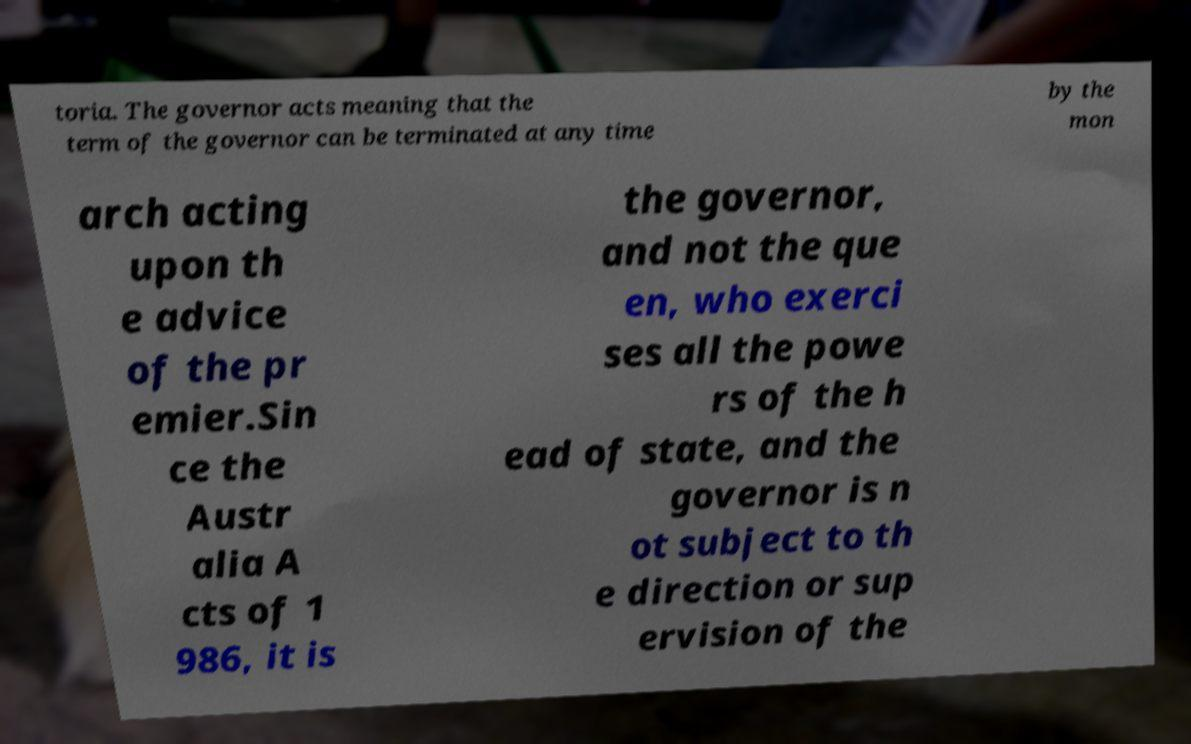Please identify and transcribe the text found in this image. toria. The governor acts meaning that the term of the governor can be terminated at any time by the mon arch acting upon th e advice of the pr emier.Sin ce the Austr alia A cts of 1 986, it is the governor, and not the que en, who exerci ses all the powe rs of the h ead of state, and the governor is n ot subject to th e direction or sup ervision of the 